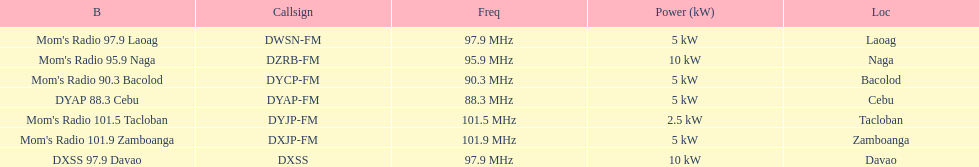How many times is the frequency greater than 95? 5. 